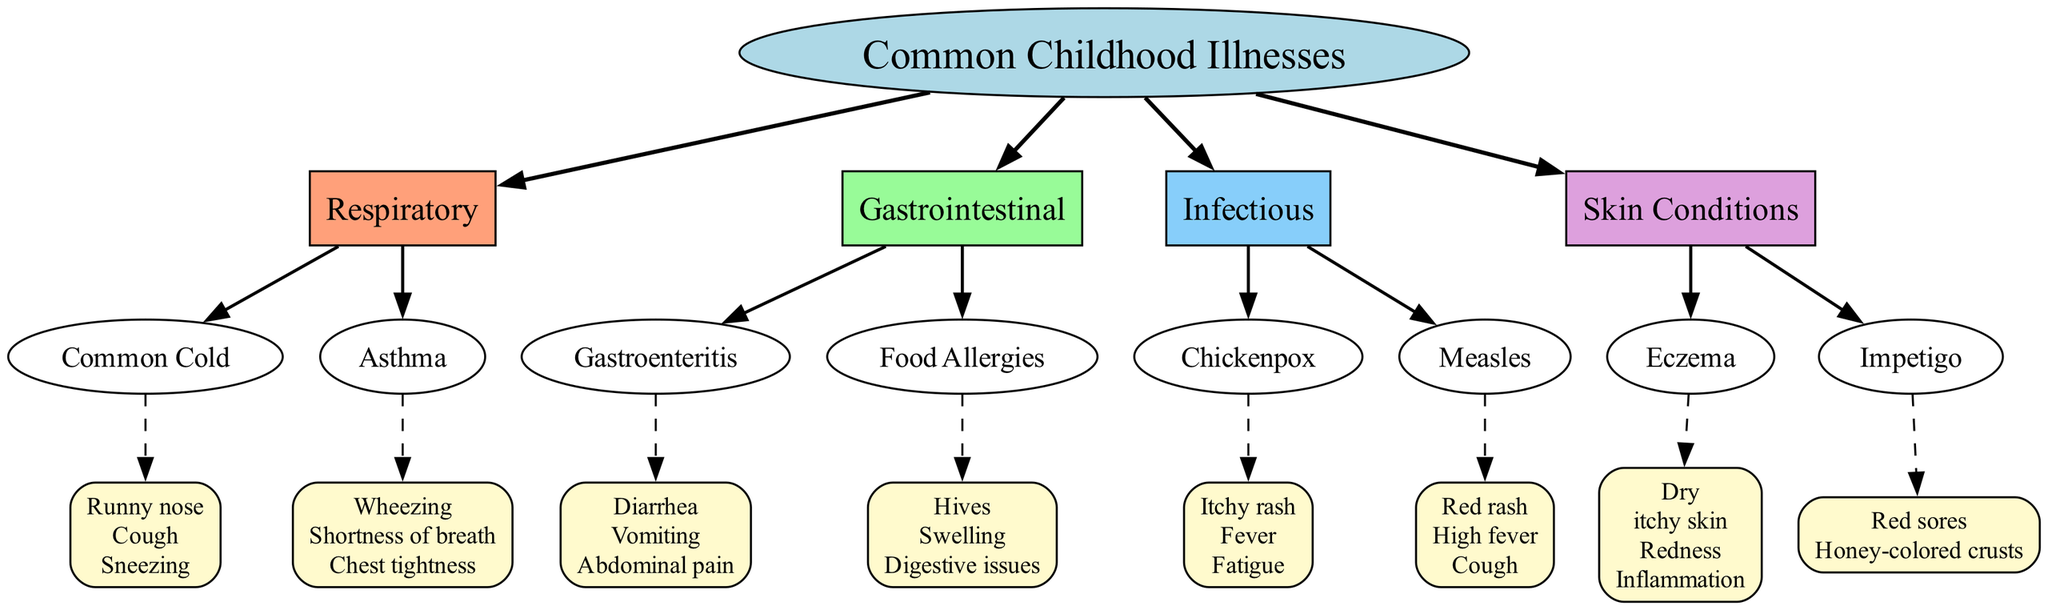What is the central topic of the diagram? The diagram identifies "Common Childhood Illnesses" as its central theme, presented at the top in a large, bold format.
Answer: Common Childhood Illnesses How many main branches are there? The diagram displays four main branches: Respiratory, Gastrointestinal, Infectious, and Skin Conditions. Counting these main branches provides the answer.
Answer: 4 What are the symptoms of Chickenpox? The diagram specifies "Itchy rash, Fever, Fatigue" directly associated with the Chickenpox sub-branch. This can be confirmed by locating the sub-branch and reading the listed symptoms.
Answer: Itchy rash, Fever, Fatigue Which main branch includes Asthma? By reviewing the major branches, it is clear that Asthma is located under the Respiratory branch. This relationship can be established by tracing the connections from Asthma to its main branch.
Answer: Respiratory What symptoms are associated with Eczema? The diagram lists "Dry, itchy skin, Redness, Inflammation" as the symptoms linked to Eczema. This can be found by following the sub-branch for Eczema and examining its symptoms.
Answer: Dry, itchy skin, Redness, Inflammation Which sub-branch has hives as a symptom? The sub-branch that lists hives is "Food Allergies." This can be determined by checking the Gastrointestinal branch for its associated symptoms.
Answer: Food Allergies What type of illness is Gastroenteritis categorized under? Gastroenteritis is categorized under the Gastrointestinal main branch. This classification can be confirmed by looking at the branches and their associated illnesses.
Answer: Gastrointestinal Which symptoms are linked to Measles? The diagram outlines "Red rash, High fever, Cough" as the symptoms of Measles. By locating the Measles sub-branch, these symptoms can be read directly.
Answer: Red rash, High fever, Cough How do Skin Conditions relate to the main topic of the diagram? Skin Conditions is one of the four main branches extending from the central topic of Common Childhood Illnesses, indicating its classification within the broader category of childhood diseases.
Answer: Skin Conditions 